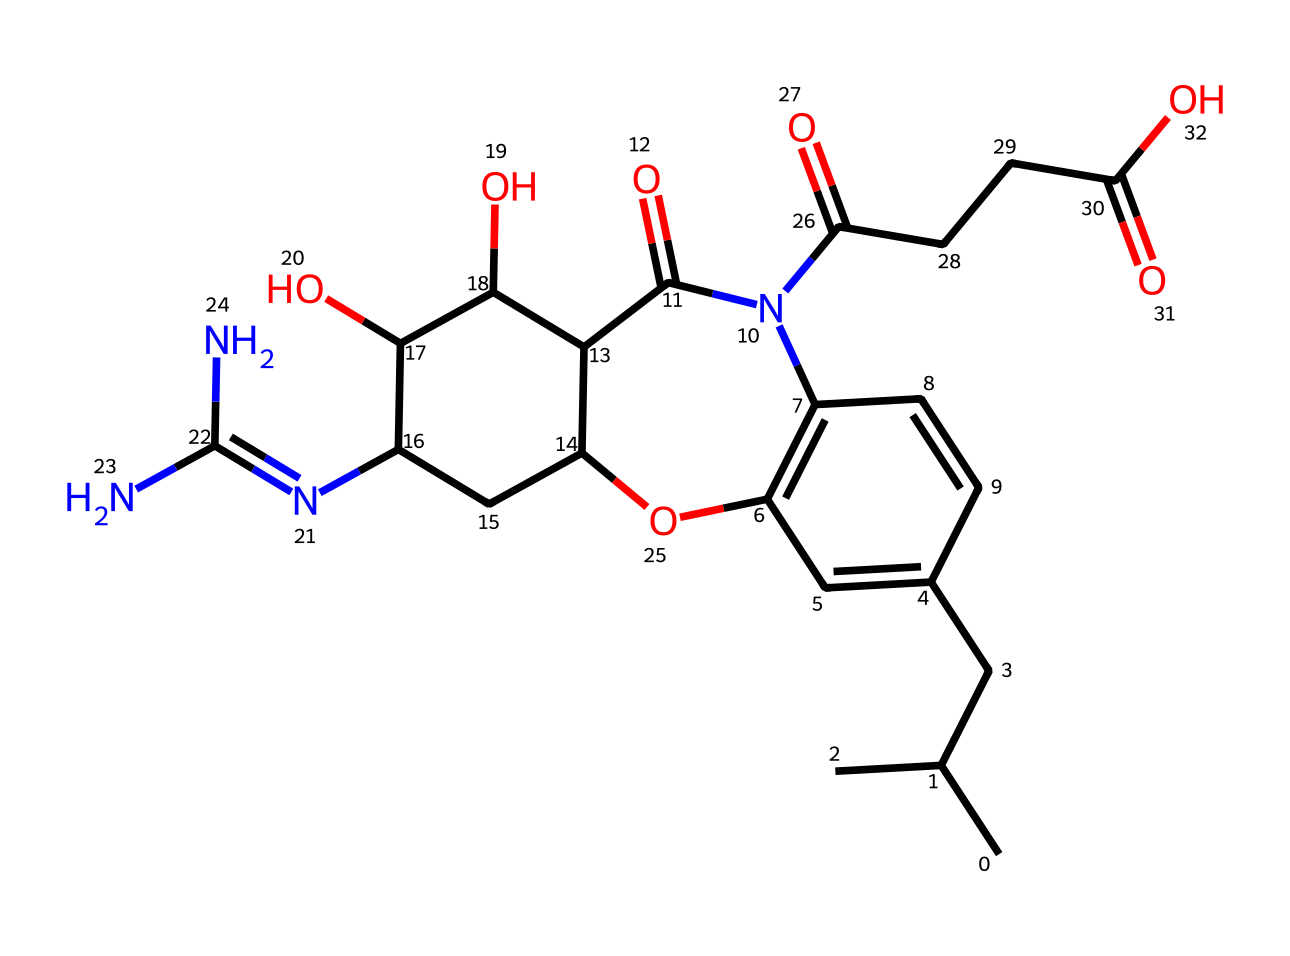What is the molecular formula of this antibiotic? To determine the molecular formula, one must identify the number of each type of atom present in the SMILES representation. Analyzing the structure reveals 19 carbons (C), 28 hydrogens (H), 6 nitrogens (N), and 6 oxygens (O), leading to the formula C19H28N6O6.
Answer: C19H28N6O6 How many rings are present in this molecule? By examining the structure represented by the SMILES, we look for cycles in the chemical. There are two distinct ring structures indicated in the representation of the antibiotic.
Answer: 2 What type of functional groups can be found in this antibiotic? Observing the structure's features shows several unique functional groups: amide groups (due to nitrogen connected to carbonyls), hydroxyl groups (due to -OH), carboxylic acids (with -COOH groups), which are characteristic of this type of antibiotic.
Answer: amide, hydroxyl, carboxylic acid Is this antibiotic a broad-spectrum or narrow-spectrum antibiotic? The presence of several functional groups and its structure indicate it has mechanisms to target a wide range of bacterial types, suggesting it is a broad-spectrum antibiotic that is effective against more than one type of pathogen.
Answer: broad-spectrum What is the significance of the nitrogen atoms in this molecule? The nitrogen atoms in this antibiotic structure are crucial as they contribute to the drug's mechanism of action, often involved in bonding with bacterial enzymes or processes. Their presence typically indicates antibacterial properties due to their role in the overall structure as part of amide or amine functional groups.
Answer: antibacterial properties How many chiral centers are there in this molecular structure? A careful examination of the molecular structure reveals that there are four stereocenters, characterized by the presence of four different substituents around these carbon atoms.
Answer: 4 What is the main mechanism of action for this type of antibiotic? By analyzing the functional groups and structure of the molecule, it can be inferred that this antibiotic likely works by inhibiting bacterial cell wall synthesis, a common mechanism among members of this class of antibiotics.
Answer: inhibiting bacterial cell wall synthesis 